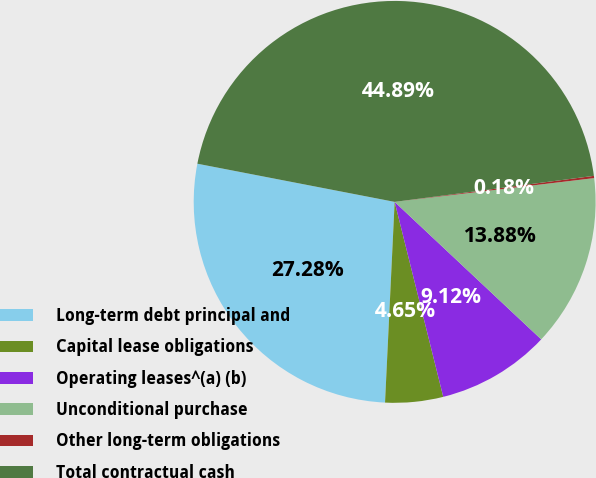Convert chart to OTSL. <chart><loc_0><loc_0><loc_500><loc_500><pie_chart><fcel>Long-term debt principal and<fcel>Capital lease obligations<fcel>Operating leases^(a) (b)<fcel>Unconditional purchase<fcel>Other long-term obligations<fcel>Total contractual cash<nl><fcel>27.28%<fcel>4.65%<fcel>9.12%<fcel>13.88%<fcel>0.18%<fcel>44.89%<nl></chart> 